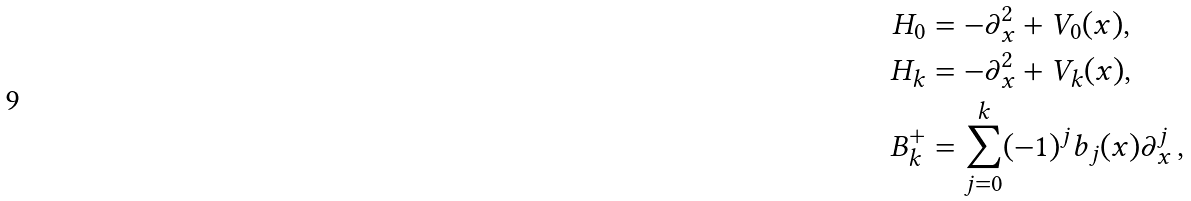Convert formula to latex. <formula><loc_0><loc_0><loc_500><loc_500>H _ { 0 } & = - \partial _ { x } ^ { 2 } + V _ { 0 } ( x ) , \\ H _ { k } & = - \partial _ { x } ^ { 2 } + V _ { k } ( x ) , \\ B _ { k } ^ { + } & = \sum _ { j = 0 } ^ { k } ( - 1 ) ^ { j } b _ { j } ( x ) \partial _ { x } ^ { j } \, ,</formula> 